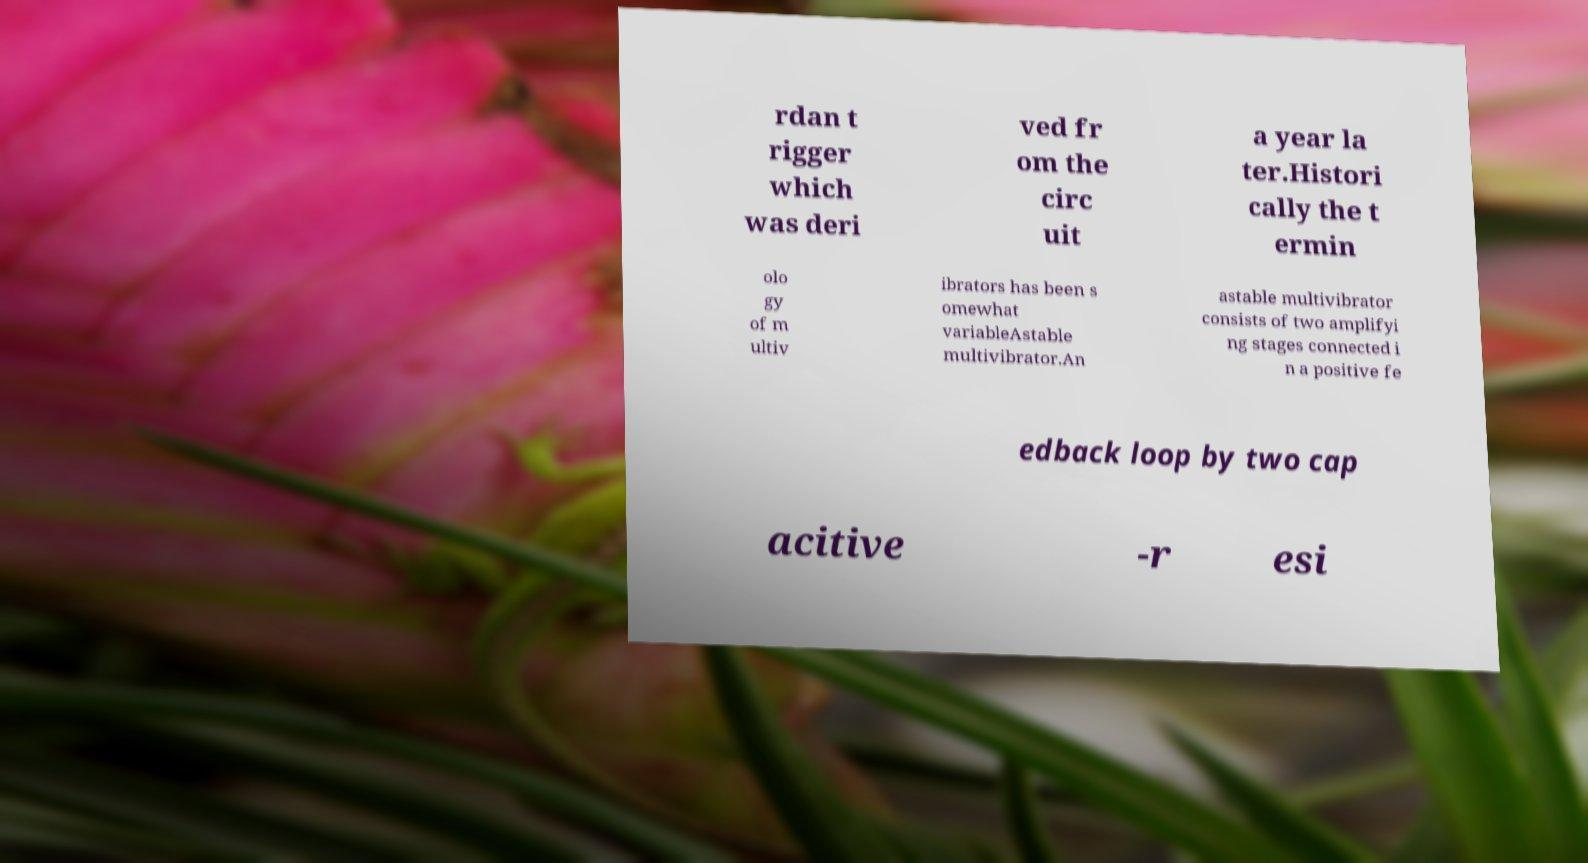There's text embedded in this image that I need extracted. Can you transcribe it verbatim? rdan t rigger which was deri ved fr om the circ uit a year la ter.Histori cally the t ermin olo gy of m ultiv ibrators has been s omewhat variableAstable multivibrator.An astable multivibrator consists of two amplifyi ng stages connected i n a positive fe edback loop by two cap acitive -r esi 